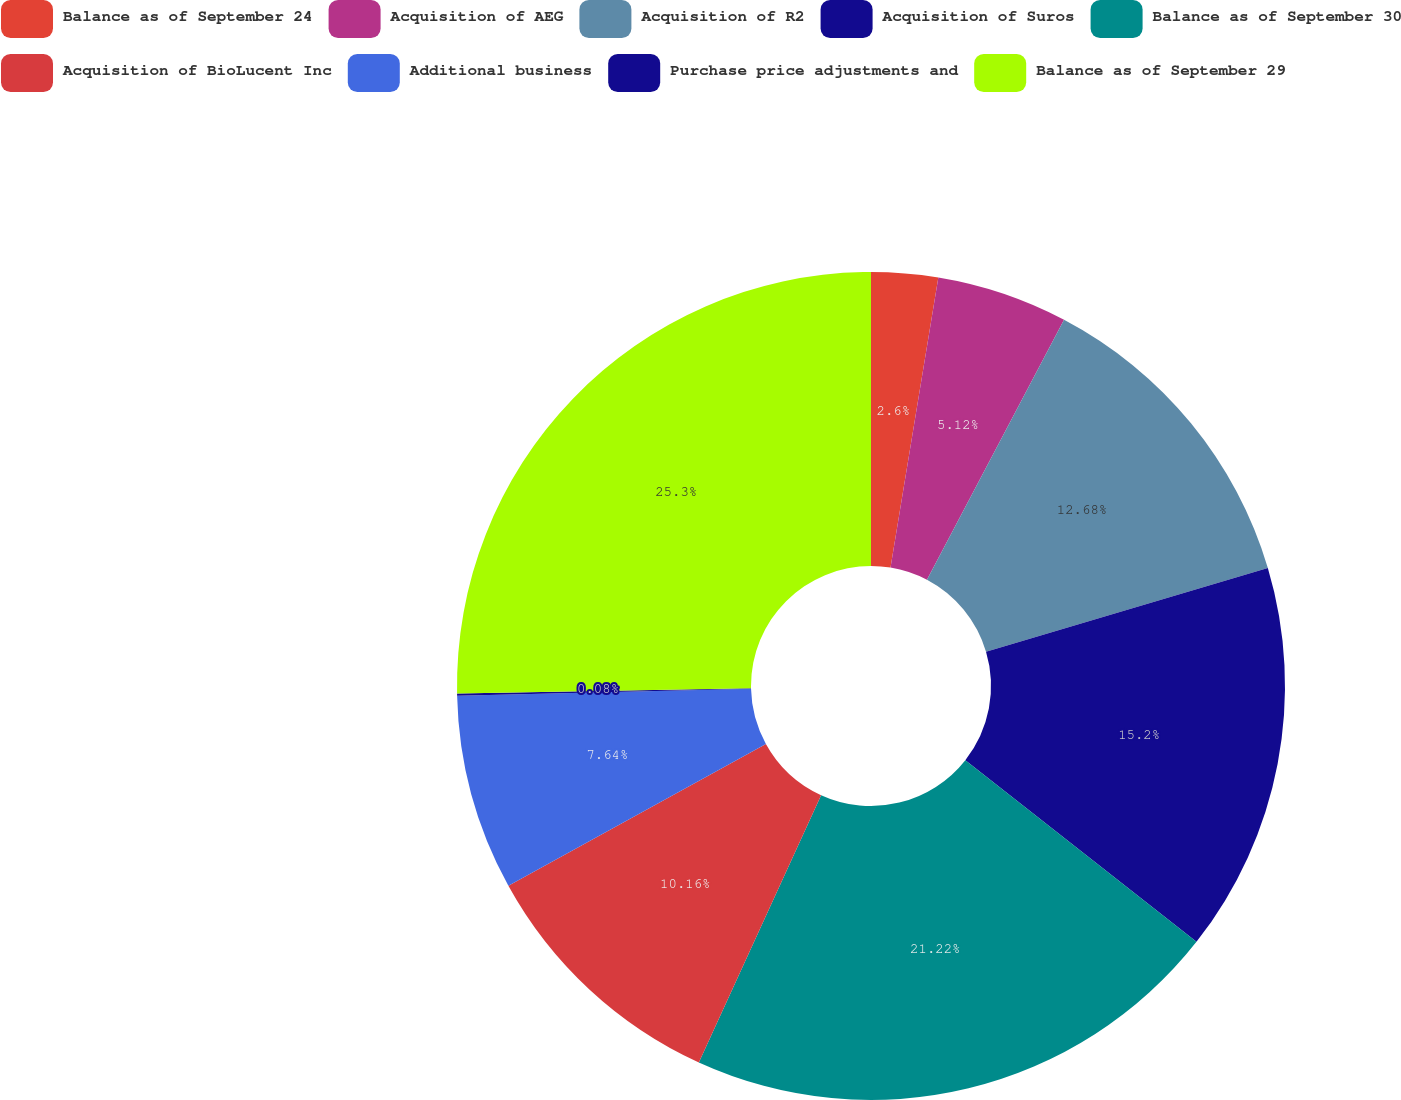<chart> <loc_0><loc_0><loc_500><loc_500><pie_chart><fcel>Balance as of September 24<fcel>Acquisition of AEG<fcel>Acquisition of R2<fcel>Acquisition of Suros<fcel>Balance as of September 30<fcel>Acquisition of BioLucent Inc<fcel>Additional business<fcel>Purchase price adjustments and<fcel>Balance as of September 29<nl><fcel>2.6%<fcel>5.12%<fcel>12.68%<fcel>15.2%<fcel>21.22%<fcel>10.16%<fcel>7.64%<fcel>0.08%<fcel>25.29%<nl></chart> 